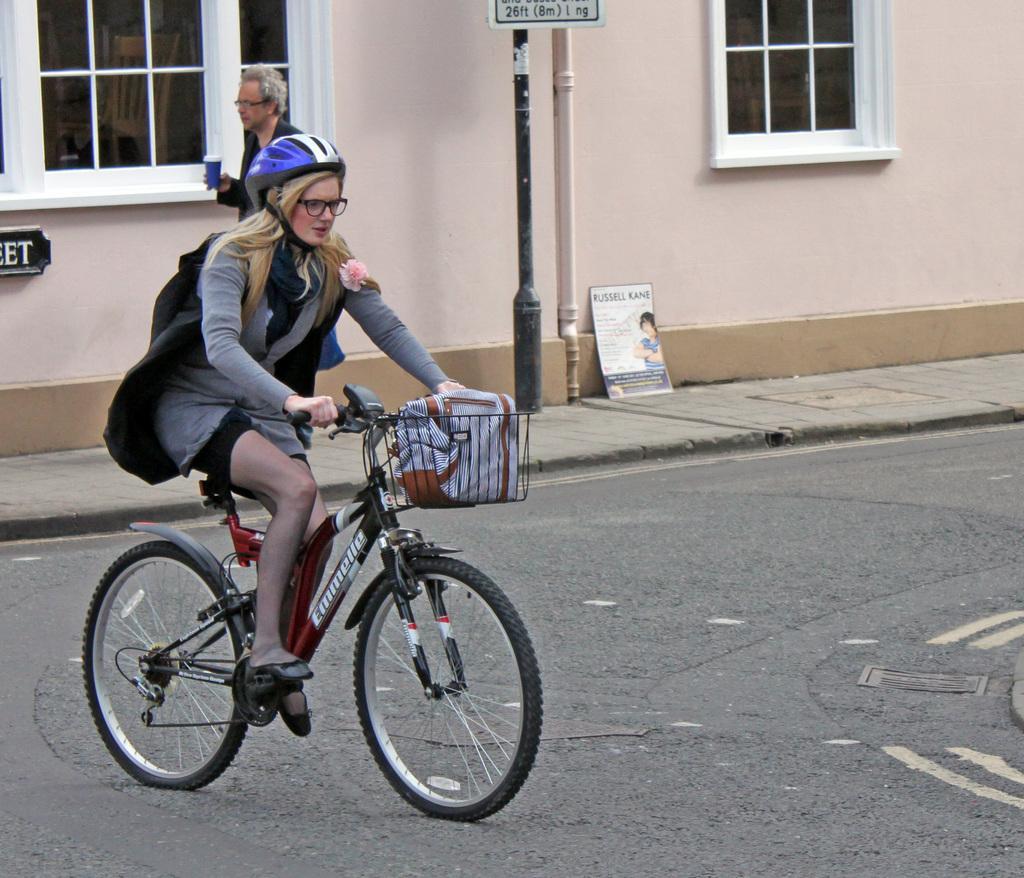In one or two sentences, can you explain what this image depicts? In this image I can see a woman is cycling a cycle. In the background I can see a man holding a cup. 